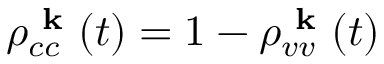Convert formula to latex. <formula><loc_0><loc_0><loc_500><loc_500>\rho _ { c c } ^ { k } ( t ) = 1 - \rho _ { v v } ^ { k } ( t )</formula> 